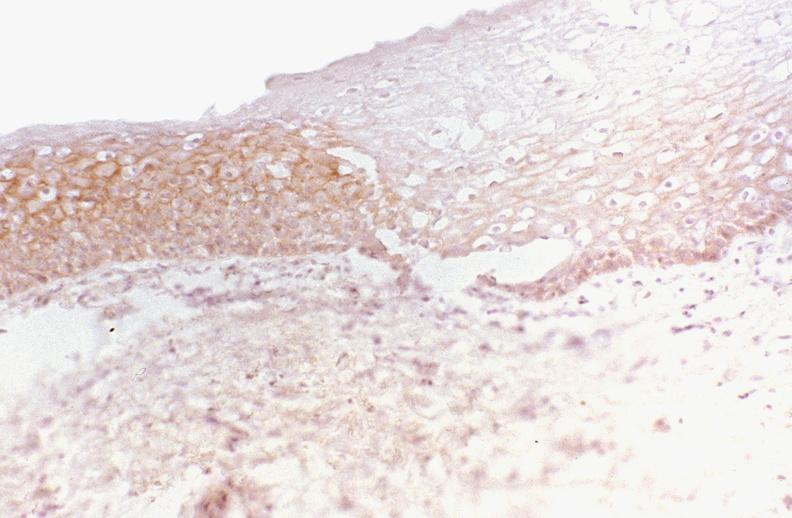what does this image show?
Answer the question using a single word or phrase. Oral dysplasia 